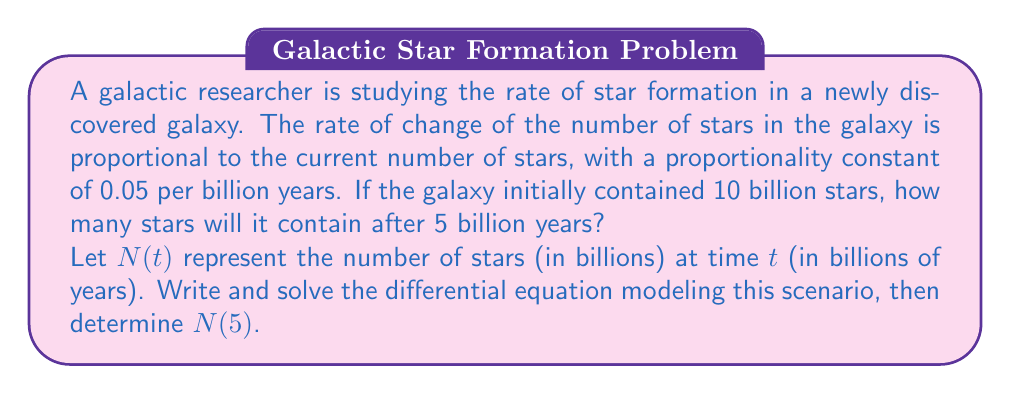Show me your answer to this math problem. Let's approach this problem step-by-step:

1) First, we need to formulate the differential equation. The rate of change of stars is proportional to the current number of stars:

   $$\frac{dN}{dt} = kN$$

   where $k$ is the proportionality constant, which is given as 0.05 per billion years.

2) Substituting the value of $k$:

   $$\frac{dN}{dt} = 0.05N$$

3) This is a separable first-order differential equation. We can solve it by separating variables:

   $$\frac{dN}{N} = 0.05dt$$

4) Integrating both sides:

   $$\int \frac{dN}{N} = \int 0.05dt$$

   $$\ln|N| = 0.05t + C$$

5) Taking the exponential of both sides:

   $$N = e^{0.05t + C} = e^C \cdot e^{0.05t}$$

6) Let $A = e^C$. Then our general solution is:

   $$N(t) = Ae^{0.05t}$$

7) To find $A$, we use the initial condition. At $t = 0$, $N = 10$ billion:

   $$10 = Ae^{0.05 \cdot 0} = A$$

8) Therefore, our particular solution is:

   $$N(t) = 10e^{0.05t}$$

9) To find the number of stars after 5 billion years, we calculate $N(5)$:

   $$N(5) = 10e^{0.05 \cdot 5} = 10e^{0.25} \approx 12.84$$
Answer: After 5 billion years, the galaxy will contain approximately 12.84 billion stars. 